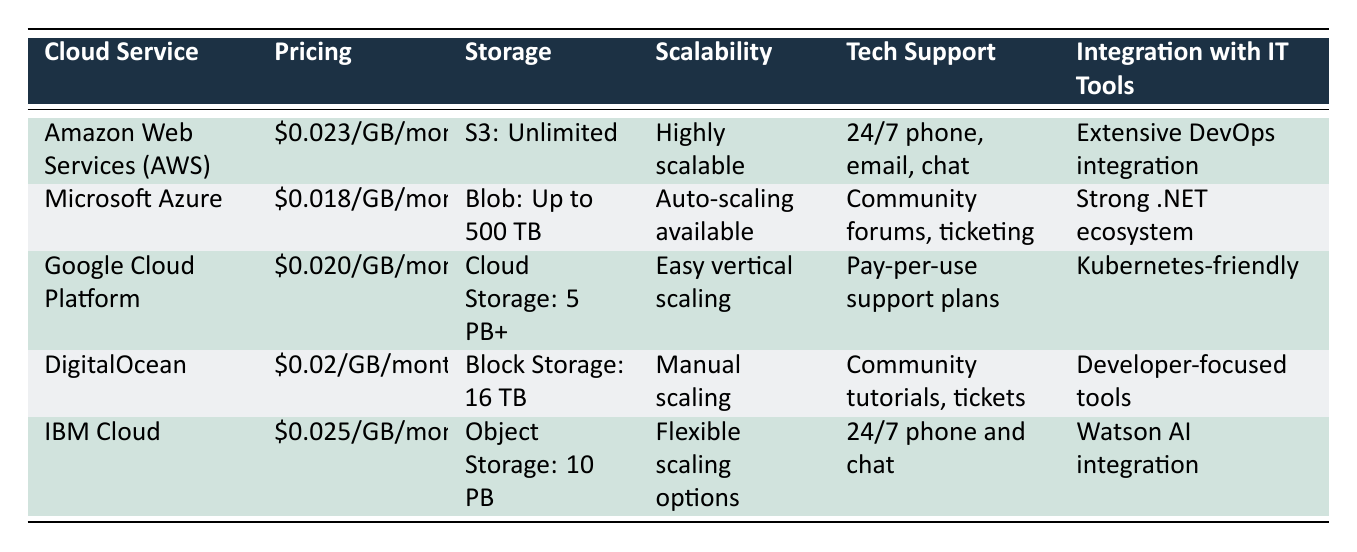What is the pricing for Microsoft Azure? The pricing for Microsoft Azure is listed in the second row of the table under the "Pricing" column as $0.018/GB/month.
Answer: $0.018/GB/month Which cloud service has the highest storage limit? The cloud service with the highest storage limit is Amazon Web Services (AWS), which offers "S3: Unlimited" storage compared to the others having specific limits.
Answer: Amazon Web Services (AWS) Is Google Cloud Platform's tech support pay-per-use? Yes, according to the "Tech Support" column in the table, Google Cloud Platform offers "Pay-per-use support plans."
Answer: Yes Which cloud service has manual scaling options? DigitalOcean provides "Manual scaling" as per the "Scalability" column in the table.
Answer: DigitalOcean What is the difference in pricing between Microsoft Azure and IBM Cloud? Microsoft Azure charges $0.018/GB/month, and IBM Cloud charges $0.025/GB/month. The difference can be calculated as $0.025 - $0.018 = $0.007.
Answer: $0.007 What is the average storage limit of the listed cloud services? The storage limits are: Unlimited (AWS), 500 TB (Azure), 5 PB+ (GCP), 16 TB (DigitalOcean), and 10 PB (IBM Cloud). Converting them to the same unit, we have: Unlimited > 500 TB, 5 PB = 5000 TB, 10 PB = 10000 TB, 16 TB. The average of (∞, 500, 5000, 16, 10000) is not calculable, but we can infer it's very high due to the unlimited storage of AWS.
Answer: Not calculable but very high Do all listed cloud services have 24/7 tech support? No, only Amazon Web Services (AWS) and IBM Cloud provide 24/7 tech support via phone and chat, while the others have community support or pay-per-use plans.
Answer: No 